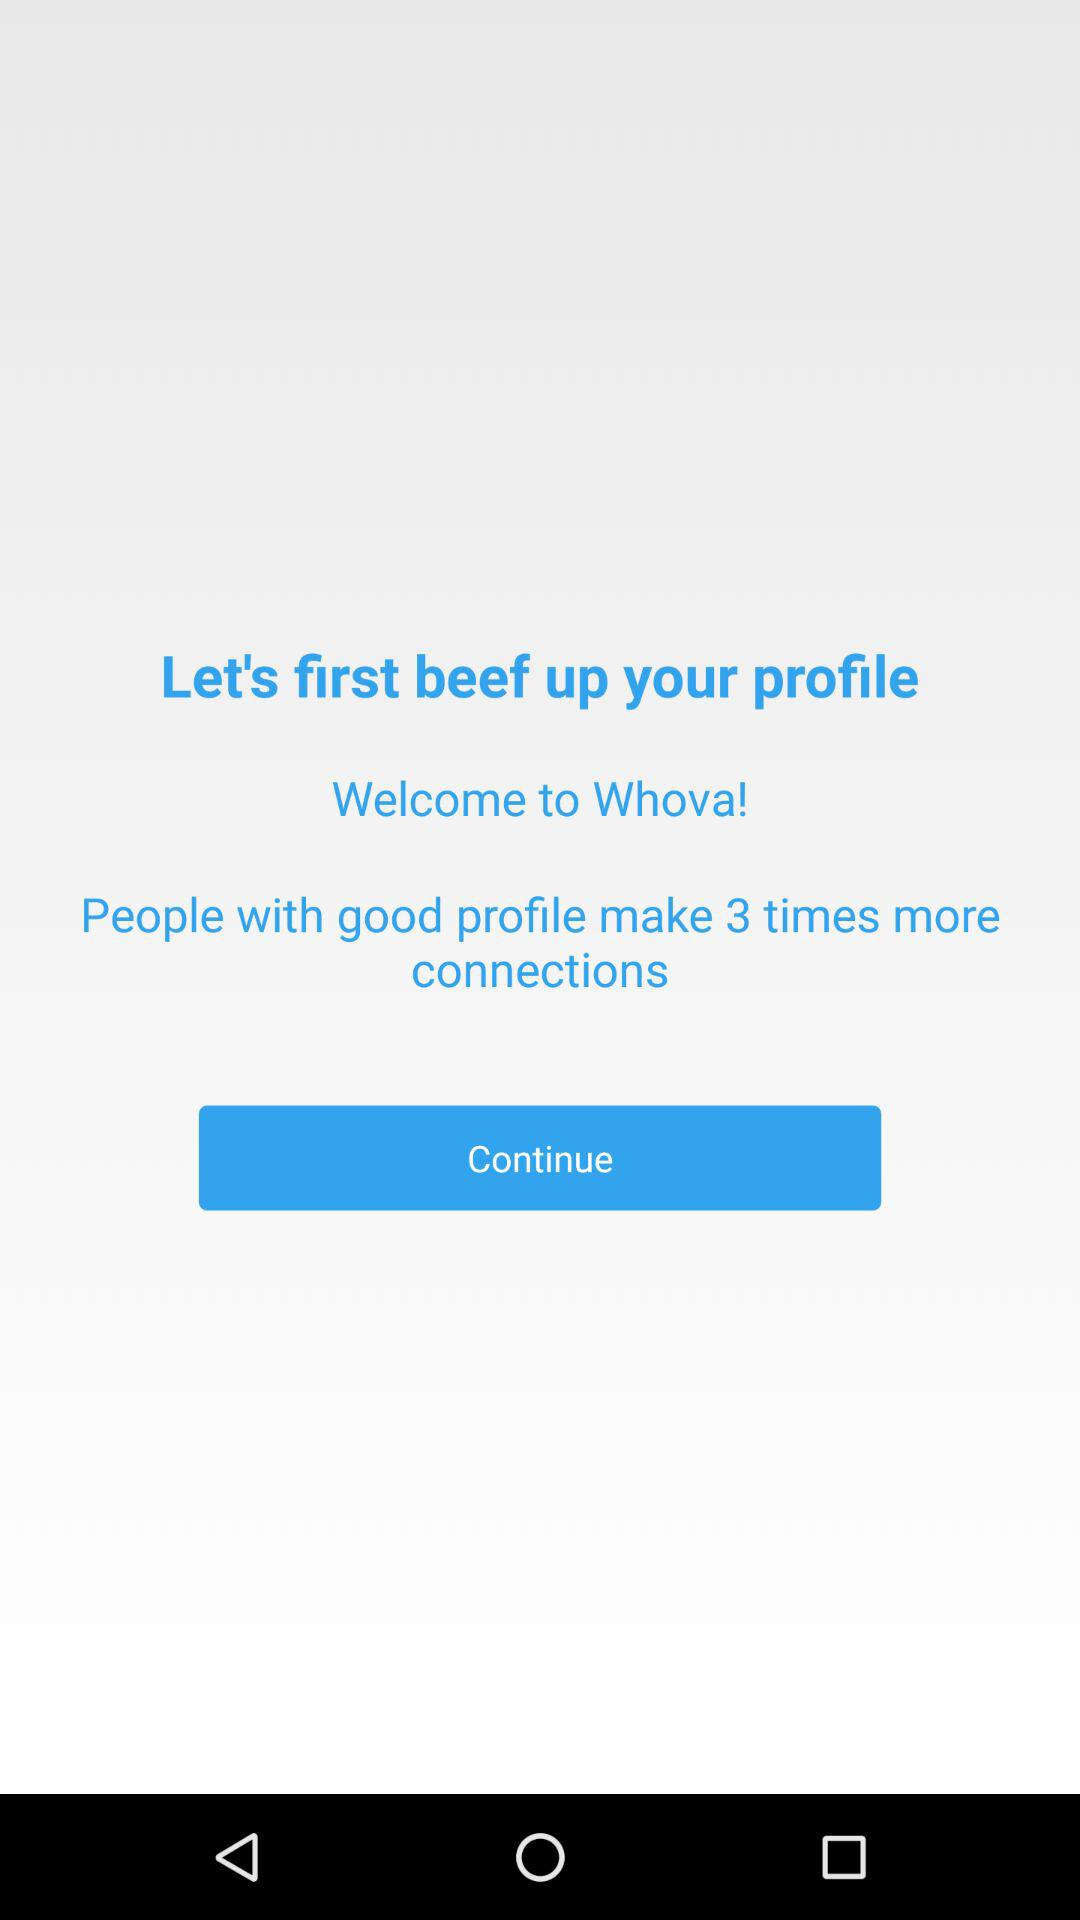How many more connections do people with good profiles make than people without?
Answer the question using a single word or phrase. 3 